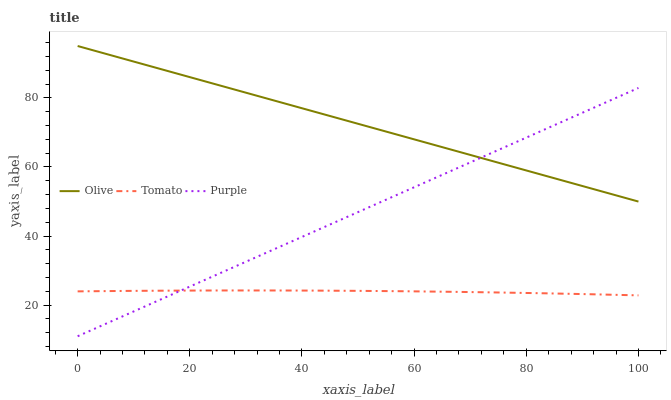Does Purple have the minimum area under the curve?
Answer yes or no. No. Does Purple have the maximum area under the curve?
Answer yes or no. No. Is Tomato the smoothest?
Answer yes or no. No. Is Purple the roughest?
Answer yes or no. No. Does Tomato have the lowest value?
Answer yes or no. No. Does Purple have the highest value?
Answer yes or no. No. Is Tomato less than Olive?
Answer yes or no. Yes. Is Olive greater than Tomato?
Answer yes or no. Yes. Does Tomato intersect Olive?
Answer yes or no. No. 